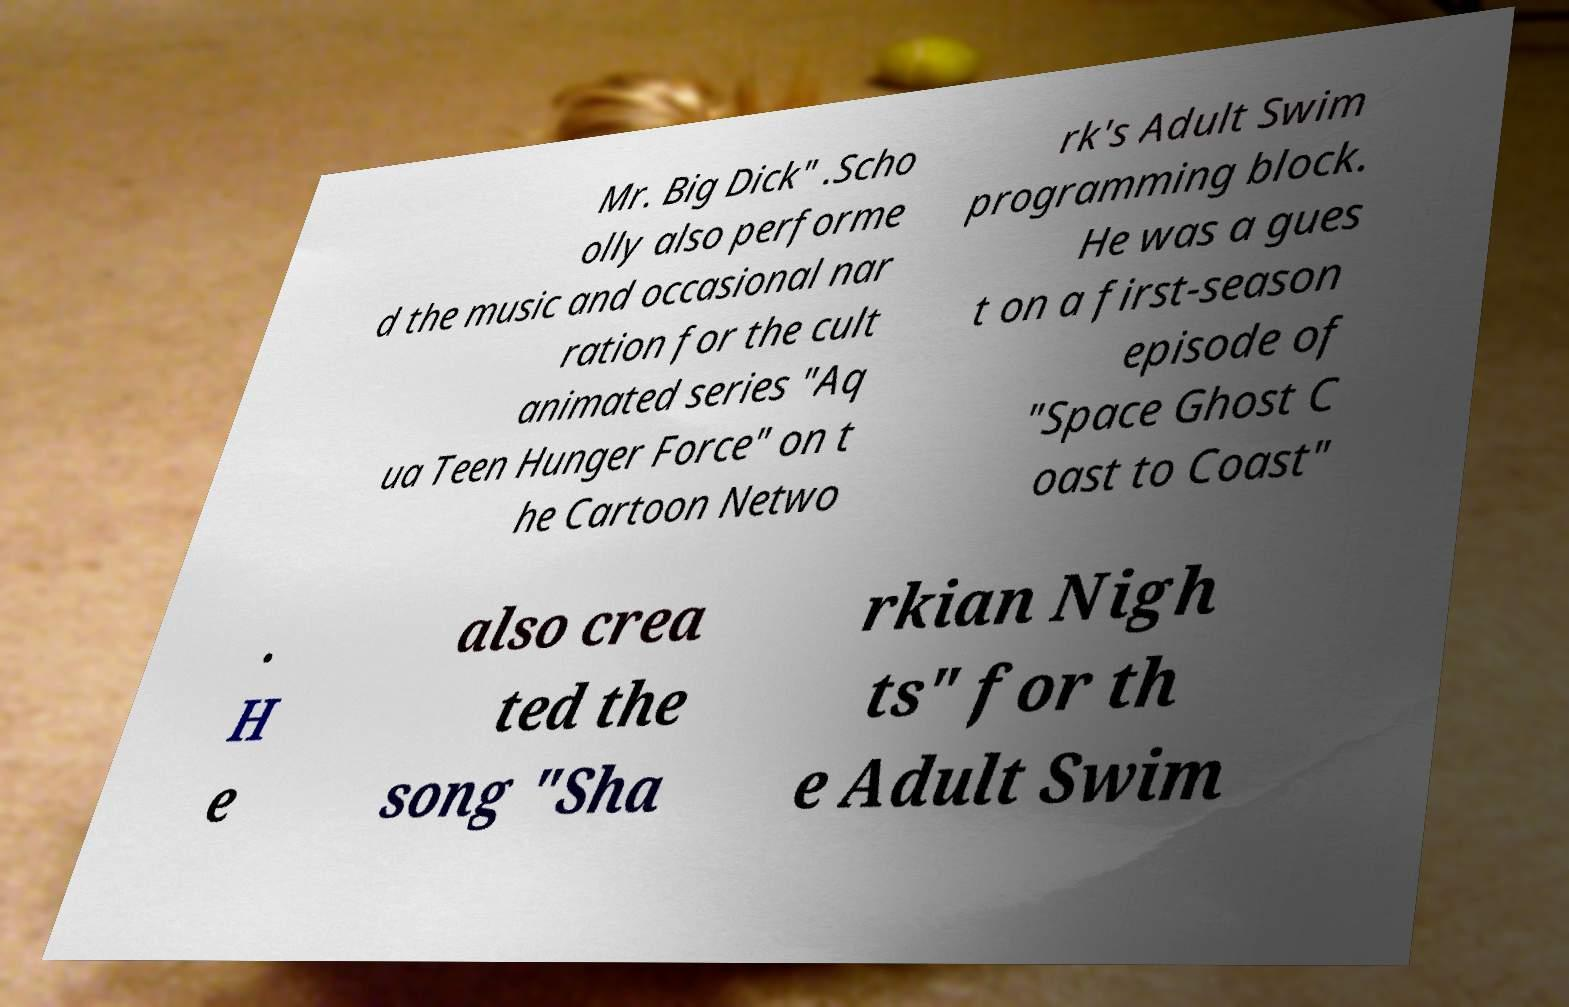For documentation purposes, I need the text within this image transcribed. Could you provide that? Mr. Big Dick" .Scho olly also performe d the music and occasional nar ration for the cult animated series "Aq ua Teen Hunger Force" on t he Cartoon Netwo rk's Adult Swim programming block. He was a gues t on a first-season episode of "Space Ghost C oast to Coast" . H e also crea ted the song "Sha rkian Nigh ts" for th e Adult Swim 